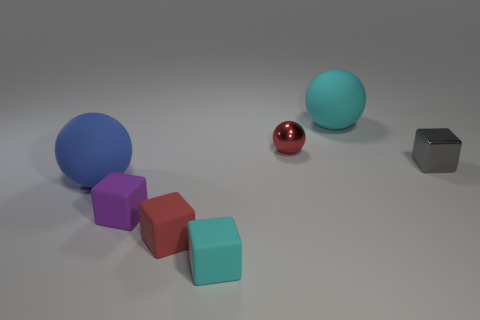Subtract all tiny red blocks. How many blocks are left? 3 Add 3 tiny purple spheres. How many objects exist? 10 Subtract 1 cubes. How many cubes are left? 3 Subtract all purple cubes. How many cubes are left? 3 Add 7 tiny red metal balls. How many tiny red metal balls are left? 8 Add 7 large balls. How many large balls exist? 9 Subtract 0 red cylinders. How many objects are left? 7 Subtract all cubes. How many objects are left? 3 Subtract all purple cubes. Subtract all purple spheres. How many cubes are left? 3 Subtract all red cylinders. How many gray blocks are left? 1 